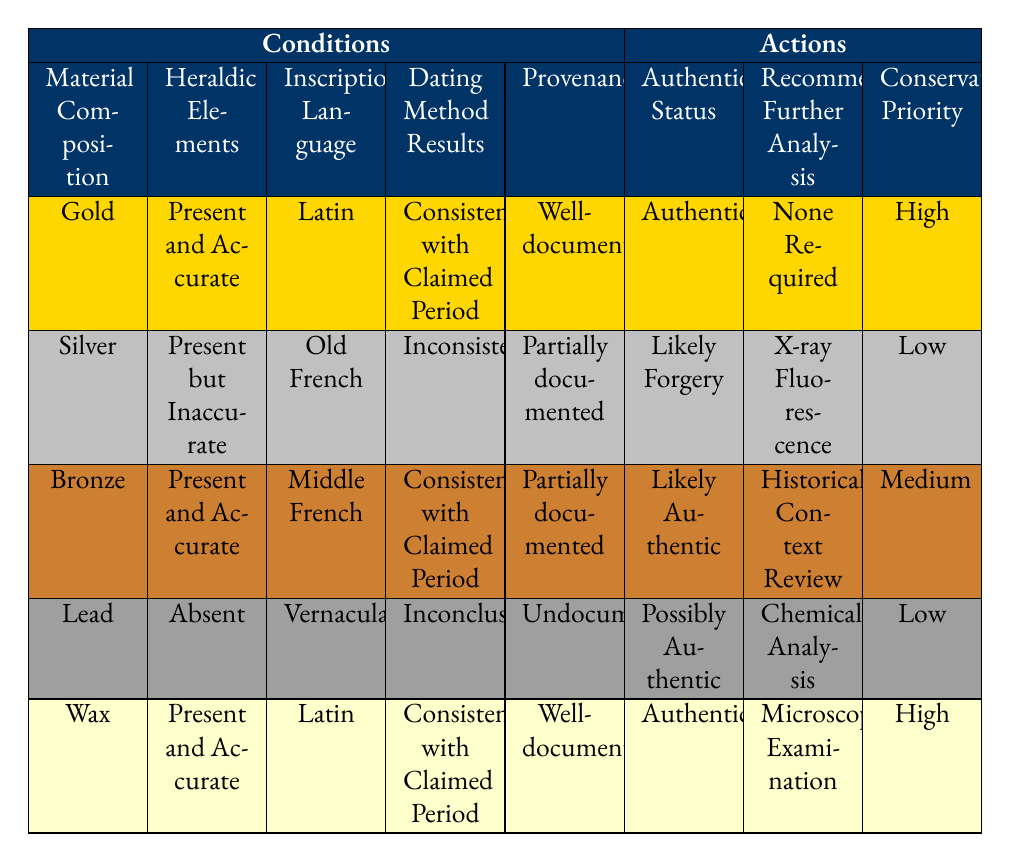What is the authentication status for emblems made of gold with accurate heraldic elements? The table shows that when the material composition is gold and the heraldic elements are present and accurate, the authentication status is classified as "Authentic."
Answer: Authentic Which material composition is associated with a high conservation priority? The table has two entries with a high conservation priority: gold and wax. The specific authentication status for both is "Authentic."
Answer: Gold and Wax Is there a case where the provenance is undocumented? Yes, in the case of lead as the material composition, with absent heraldic elements and an inconclusive dating method, the provenance is listed as undocumented.
Answer: Yes What is the recommended further analysis for the emblem that is likely authentic? For the emblem categorized as likely authentic (which uses bronze, has accurate heraldic elements, and a consistent dating method), the recommended further analysis is "Historical Context Review."
Answer: Historical Context Review How many emblems have an authentication status of likely forgery? There is one emblem with an authentication status of likely forgery, which is made of silver, has inaccurate heraldic elements, and is partially documented.
Answer: 1 If an emblem is made of wax, what is the status assigned to it? The table indicates that for wax with present and accurate heraldic elements, a Latin inscription, consistent dating results, and well-documented provenance, the authentication status is "Authentic."
Answer: Authentic For the emblem made of lead, which recommended further analysis is suggested? The emblem made of lead is classified as possibly authentic, and the recommended further analysis for it is "Chemical Analysis."
Answer: Chemical Analysis Is it true that all emblems with well-documented provenance are authenticated as authentic? No, while both gold and wax emblems with well-documented provenance are authentic, there is a bronze emblem with partially documented provenance that is likely authentic.
Answer: No What is the average conservation priority of the emblems listed in the table? The conservation priorities listed are high, medium, and low. There are two emblems marked as high, one as medium, and two as low. Therefore, calculating an average based on the priority distribution results in a weighted average leaning towards high. However, since this is categorical data, one could generally summarize that the majority are either high or medium.
Answer: Mostly High What conditions lead to an emblem being classified as likely forgery? An emblem is classified as likely forgery if it is made of silver, has present but inaccurate heraldic elements, has its inscription in Old French, yields inconsistent dating method results, and is partially documented.
Answer: Silver, Present but Inaccurate, Old French, Inconsistent, Partially documented 